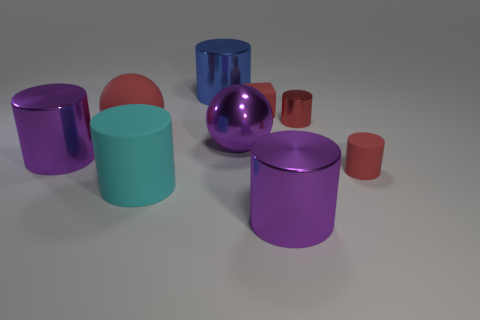Is the size of the red metal cylinder the same as the blue metal cylinder?
Your response must be concise. No. Are there fewer large objects on the left side of the large blue metal object than big purple shiny cylinders on the left side of the big red matte ball?
Keep it short and to the point. No. Is there any other thing that has the same size as the cyan cylinder?
Offer a terse response. Yes. How big is the cyan rubber cylinder?
Your response must be concise. Large. What number of big things are red cylinders or purple objects?
Give a very brief answer. 3. There is a red metallic thing; does it have the same size as the sphere right of the large rubber ball?
Give a very brief answer. No. Is there anything else that has the same shape as the big cyan rubber object?
Give a very brief answer. Yes. What number of large purple cylinders are there?
Offer a very short reply. 2. How many cyan objects are big rubber cylinders or small matte blocks?
Give a very brief answer. 1. Does the ball right of the cyan cylinder have the same material as the cyan cylinder?
Offer a terse response. No. 